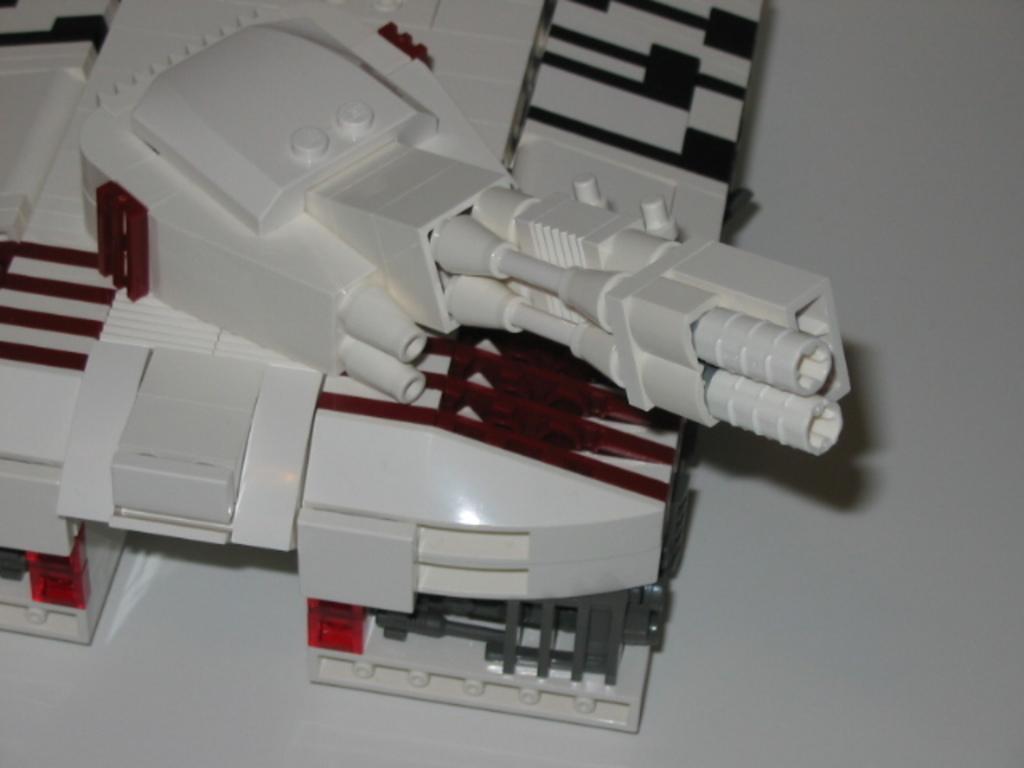Can you describe this image briefly? In this image I can see a toy machine on the floor. This image is taken may be in a room. 